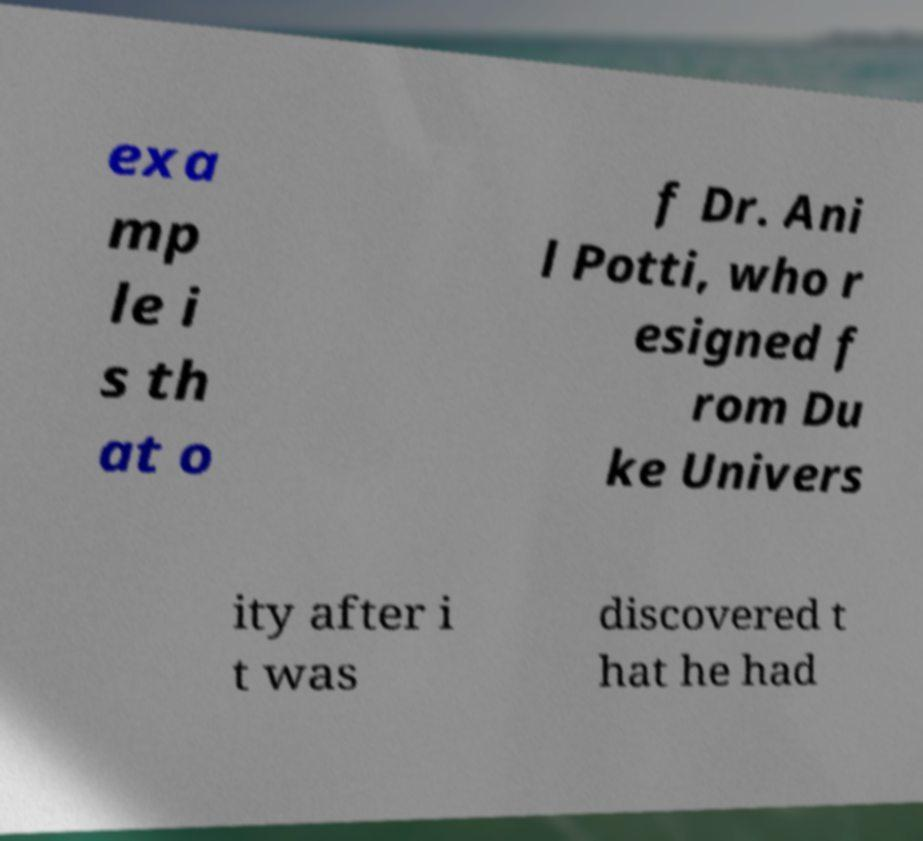Can you accurately transcribe the text from the provided image for me? exa mp le i s th at o f Dr. Ani l Potti, who r esigned f rom Du ke Univers ity after i t was discovered t hat he had 